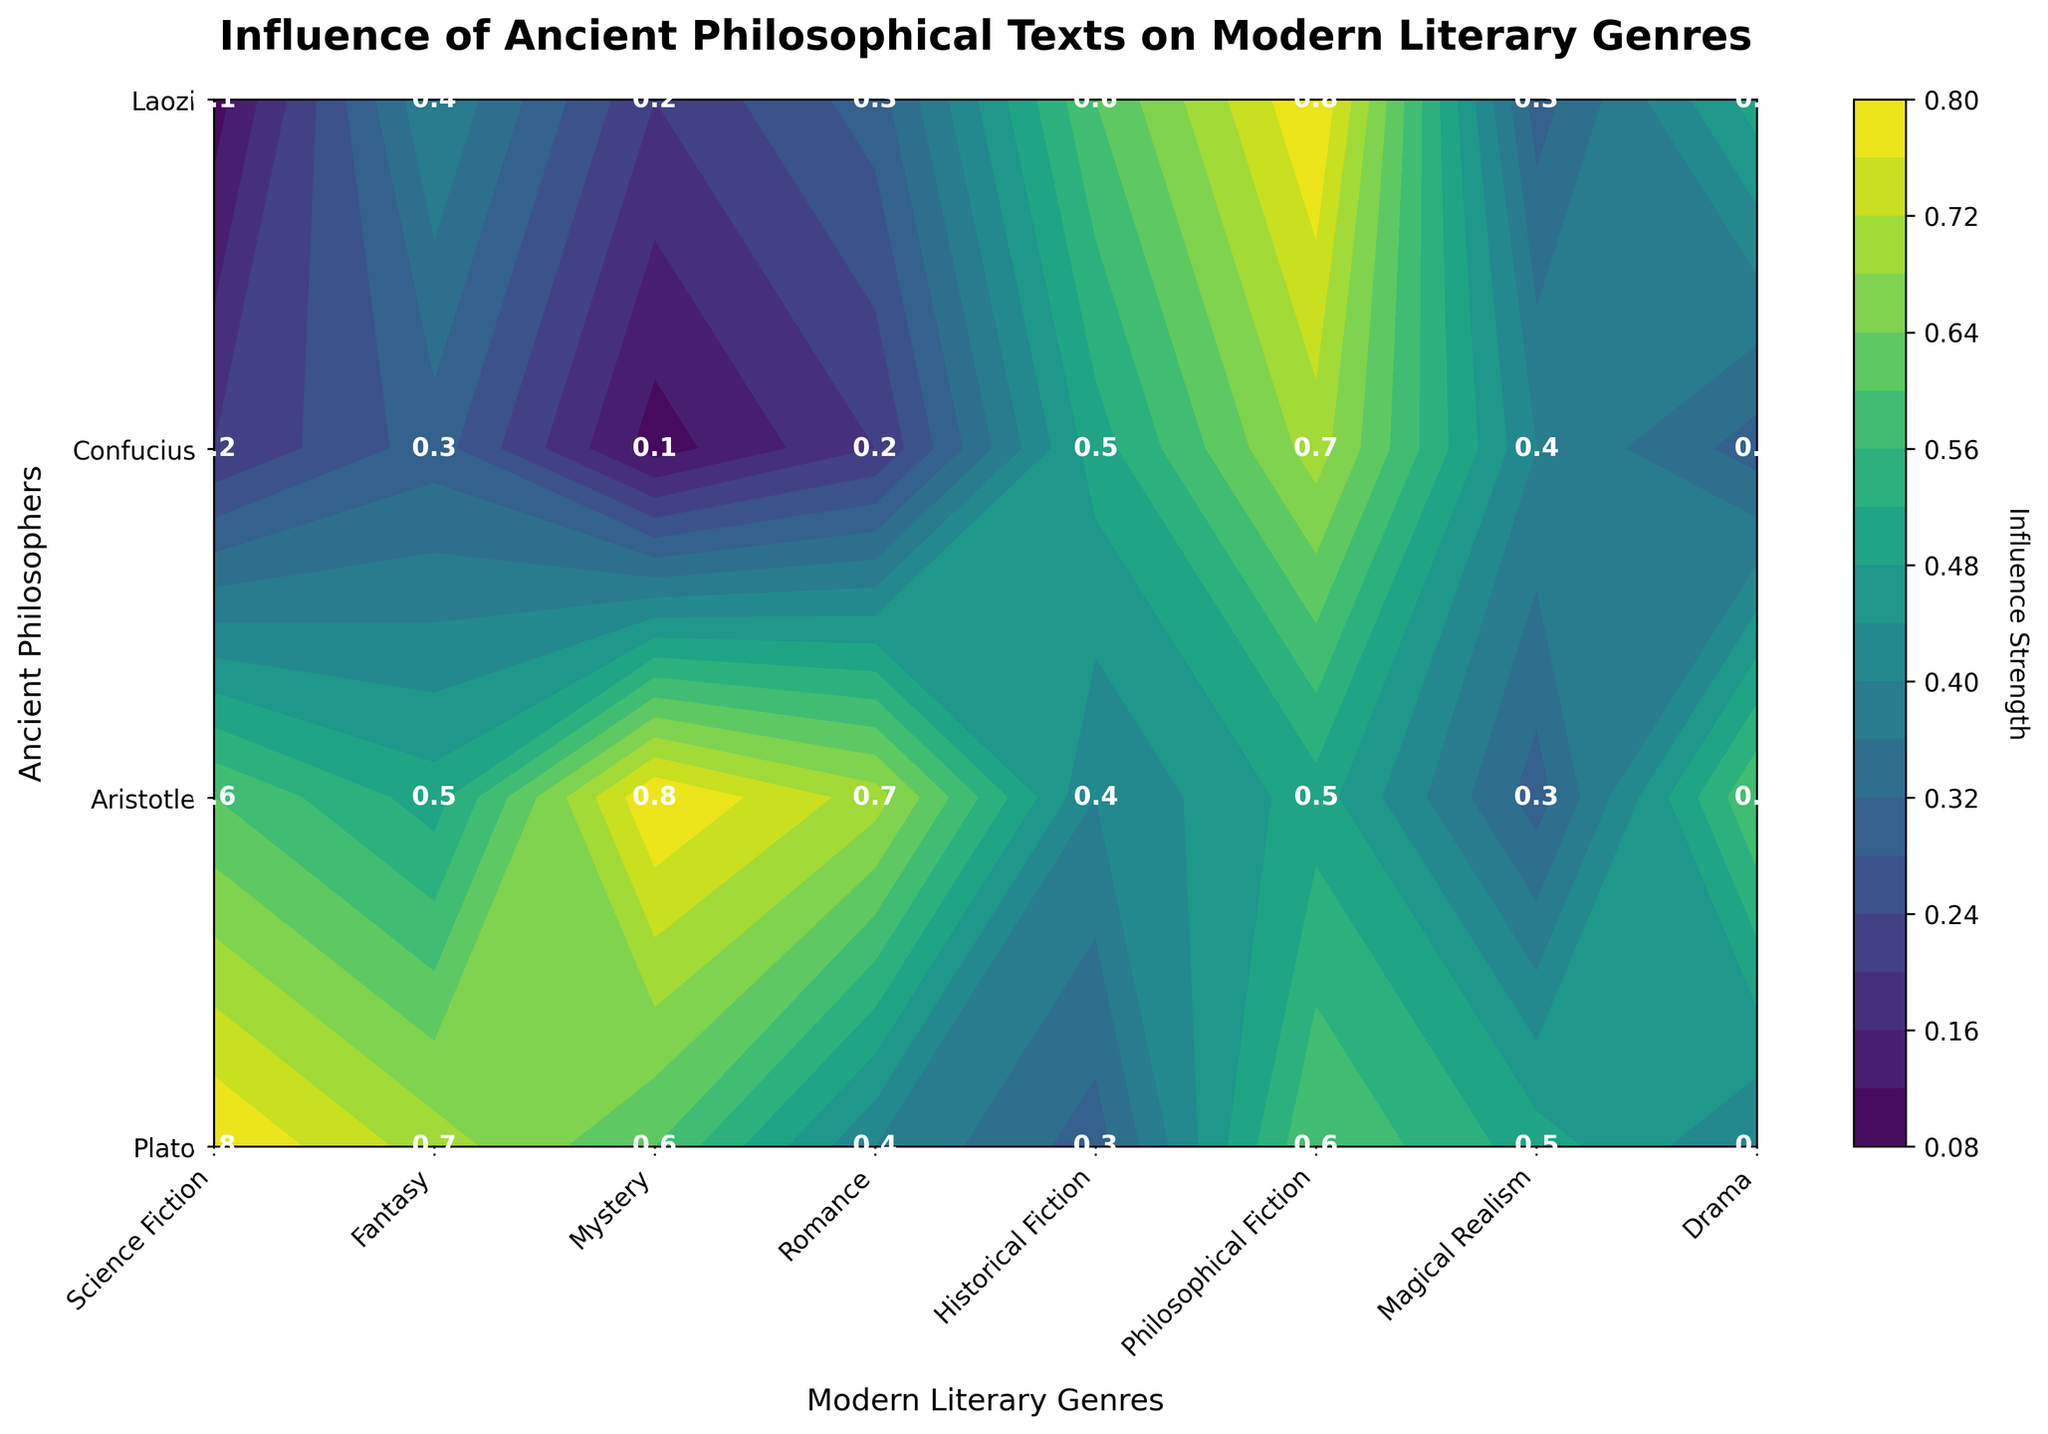What is the title of the plot? The title of the plot is displayed at the top of the figure. It helps understand what the plot is about.
Answer: Influence of Ancient Philosophical Texts on Modern Literary Genres Which philosopher has the highest influence on Science Fiction in North America? To find this, locate the "Science Fiction" column on the x-axis and look for the highest value among the philosophers.
Answer: Plato Which region has the genre with the highest influence from Confucius? Check the values under Confucius and see which genre has the highest influence. Then identify the corresponding region for that genre.
Answer: Asia (Philosophical Fiction) How many modern literary genres are displayed in the plot? Count the number of unique labels on the x-axis to determine the number of modern literary genres.
Answer: 7 Which genre in Europe is influenced more by Aristotle than by Plato? Identify the genres in Europe and compare the values of Aristotle and Plato for each genre. Look for genres where Aristotle's influence is higher.
Answer: Mystery In which region does Laozi have a greater influence on Drama compared to Confucius? Find the "Drama" genre and compare the values of Laozi and Confucius. Determine the corresponding region where Laozi's influence is greater.
Answer: Africa Calculate the average influence of Laozi across all genres in Asia. Find the genres in Asia and add the Laozi values. Then divide by the number of genres in Asia.
Answer: (0.6 + 0.8) / 2 = 0.7 Which philosopher has the lowest average influence across all genres? Sum the influence values for each philosopher and divide by the total number of genres to get the average. Identify the philosopher with the lowest average.
Answer: Confucius In which region does Plato have a higher influence on Fantasy than on any other genre? Locate the Fantasy column and compare Plato's value to his influence on other genres within the same region.
Answer: North America Which genre has the closest influence values for Plato and Aristotle? Compare the influence values for Plato and Aristotle in each genre and determine the genre with the smallest difference.
Answer: Philosophical Fiction 